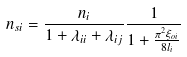Convert formula to latex. <formula><loc_0><loc_0><loc_500><loc_500>n _ { s i } = \frac { n _ { i } } { 1 + \lambda _ { i i } + \lambda _ { i j } } \frac { 1 } { 1 + \frac { \pi ^ { 2 } \xi _ { o i } } { 8 l _ { i } } }</formula> 